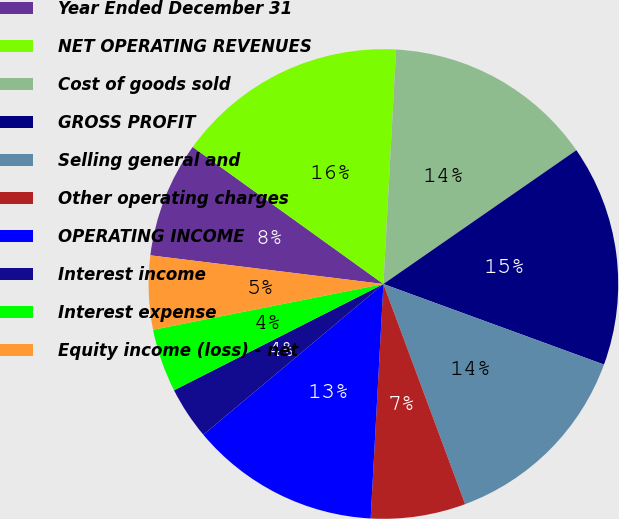Convert chart to OTSL. <chart><loc_0><loc_0><loc_500><loc_500><pie_chart><fcel>Year Ended December 31<fcel>NET OPERATING REVENUES<fcel>Cost of goods sold<fcel>GROSS PROFIT<fcel>Selling general and<fcel>Other operating charges<fcel>OPERATING INCOME<fcel>Interest income<fcel>Interest expense<fcel>Equity income (loss) - net<nl><fcel>7.97%<fcel>15.94%<fcel>14.49%<fcel>15.22%<fcel>13.77%<fcel>6.52%<fcel>13.04%<fcel>3.62%<fcel>4.35%<fcel>5.07%<nl></chart> 